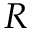Convert formula to latex. <formula><loc_0><loc_0><loc_500><loc_500>R</formula> 